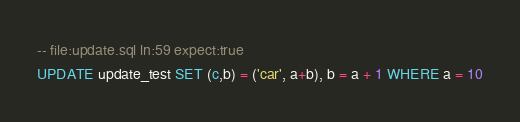<code> <loc_0><loc_0><loc_500><loc_500><_SQL_>-- file:update.sql ln:59 expect:true
UPDATE update_test SET (c,b) = ('car', a+b), b = a + 1 WHERE a = 10
</code> 